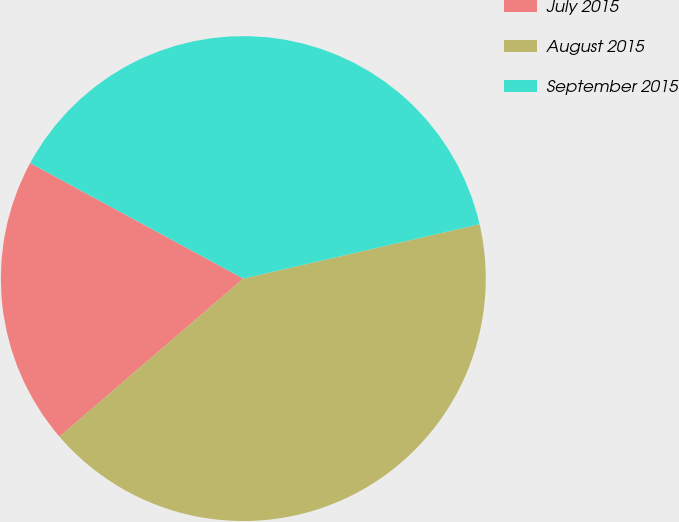<chart> <loc_0><loc_0><loc_500><loc_500><pie_chart><fcel>July 2015<fcel>August 2015<fcel>September 2015<nl><fcel>19.21%<fcel>42.3%<fcel>38.5%<nl></chart> 